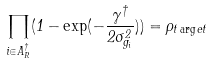Convert formula to latex. <formula><loc_0><loc_0><loc_500><loc_500>\prod _ { i \in A _ { R } ^ { \dag } } ( 1 - \exp ( - \frac { \gamma ^ { \dag } } { 2 \sigma _ { g _ { i } } ^ { 2 } } ) ) = \rho _ { t \arg e t }</formula> 